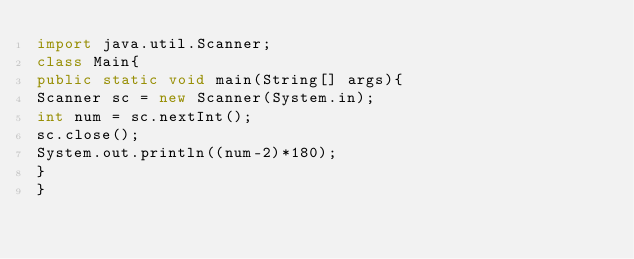Convert code to text. <code><loc_0><loc_0><loc_500><loc_500><_Java_>import java.util.Scanner;
class Main{
public static void main(String[] args){
Scanner sc = new Scanner(System.in);
int num = sc.nextInt();
sc.close();
System.out.println((num-2)*180);
}
}</code> 